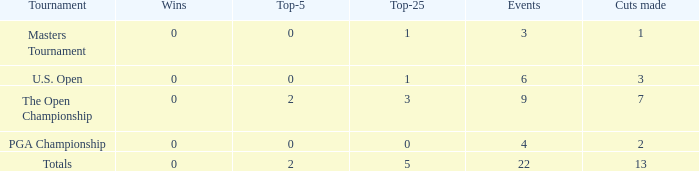What is the average number of cuts made for events with under 4 entries and more than 0 wins? None. 